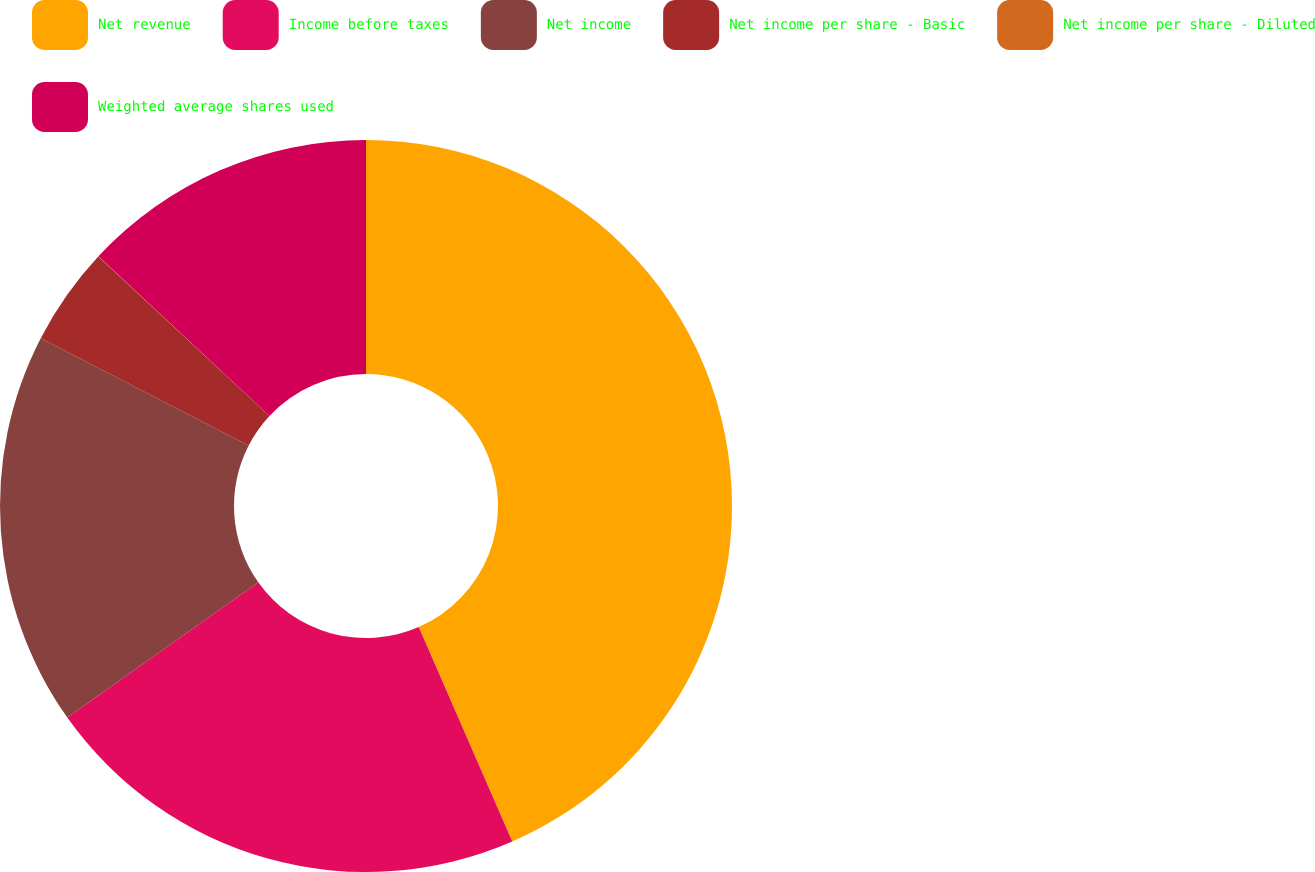<chart> <loc_0><loc_0><loc_500><loc_500><pie_chart><fcel>Net revenue<fcel>Income before taxes<fcel>Net income<fcel>Net income per share - Basic<fcel>Net income per share - Diluted<fcel>Weighted average shares used<nl><fcel>43.46%<fcel>21.74%<fcel>17.39%<fcel>4.36%<fcel>0.01%<fcel>13.05%<nl></chart> 